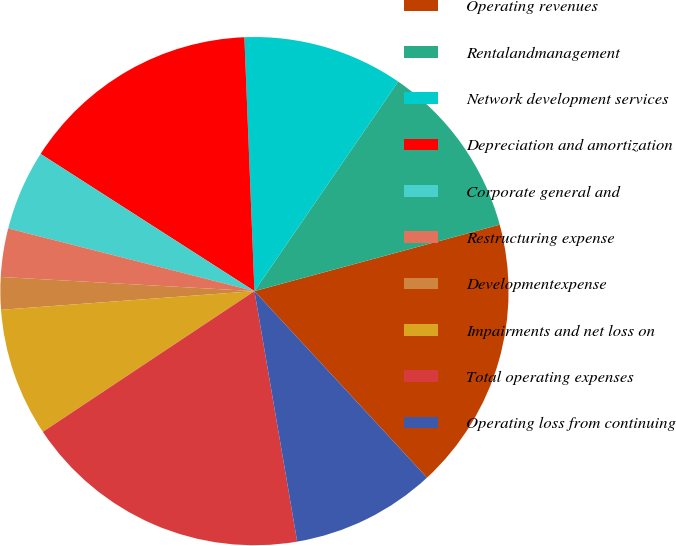Convert chart to OTSL. <chart><loc_0><loc_0><loc_500><loc_500><pie_chart><fcel>Operating revenues<fcel>Rentalandmanagement<fcel>Network development services<fcel>Depreciation and amortization<fcel>Corporate general and<fcel>Restructuring expense<fcel>Developmentexpense<fcel>Impairments and net loss on<fcel>Total operating expenses<fcel>Operating loss from continuing<nl><fcel>17.33%<fcel>11.22%<fcel>10.2%<fcel>15.29%<fcel>5.11%<fcel>3.08%<fcel>2.06%<fcel>8.17%<fcel>18.35%<fcel>9.19%<nl></chart> 